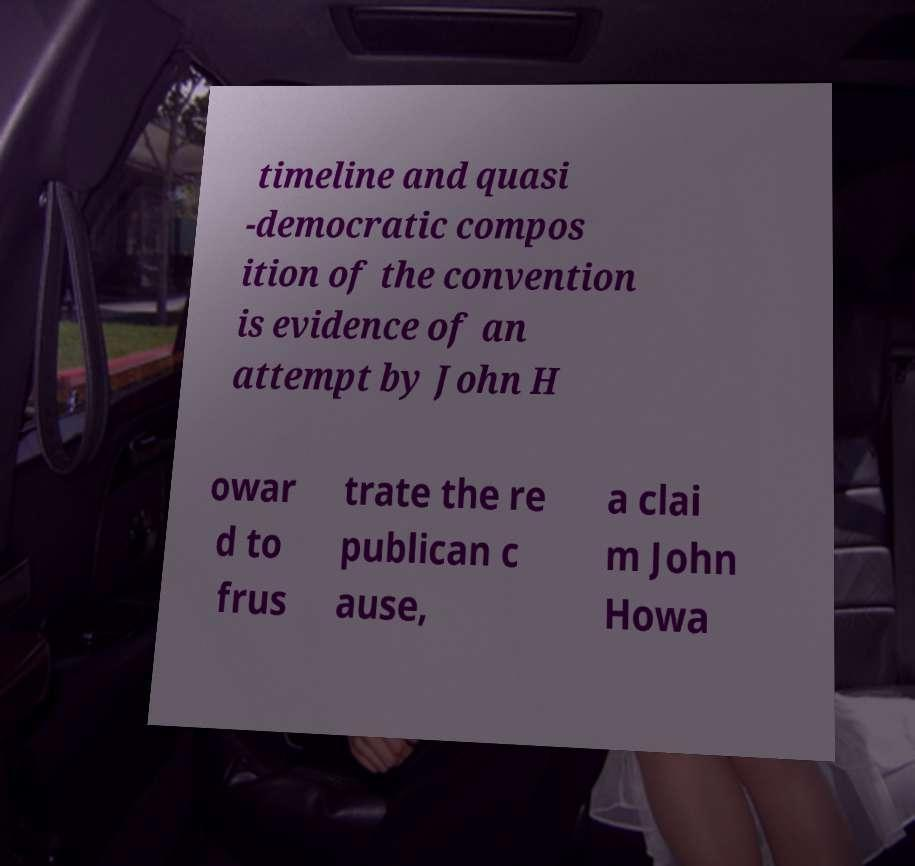What messages or text are displayed in this image? I need them in a readable, typed format. timeline and quasi -democratic compos ition of the convention is evidence of an attempt by John H owar d to frus trate the re publican c ause, a clai m John Howa 